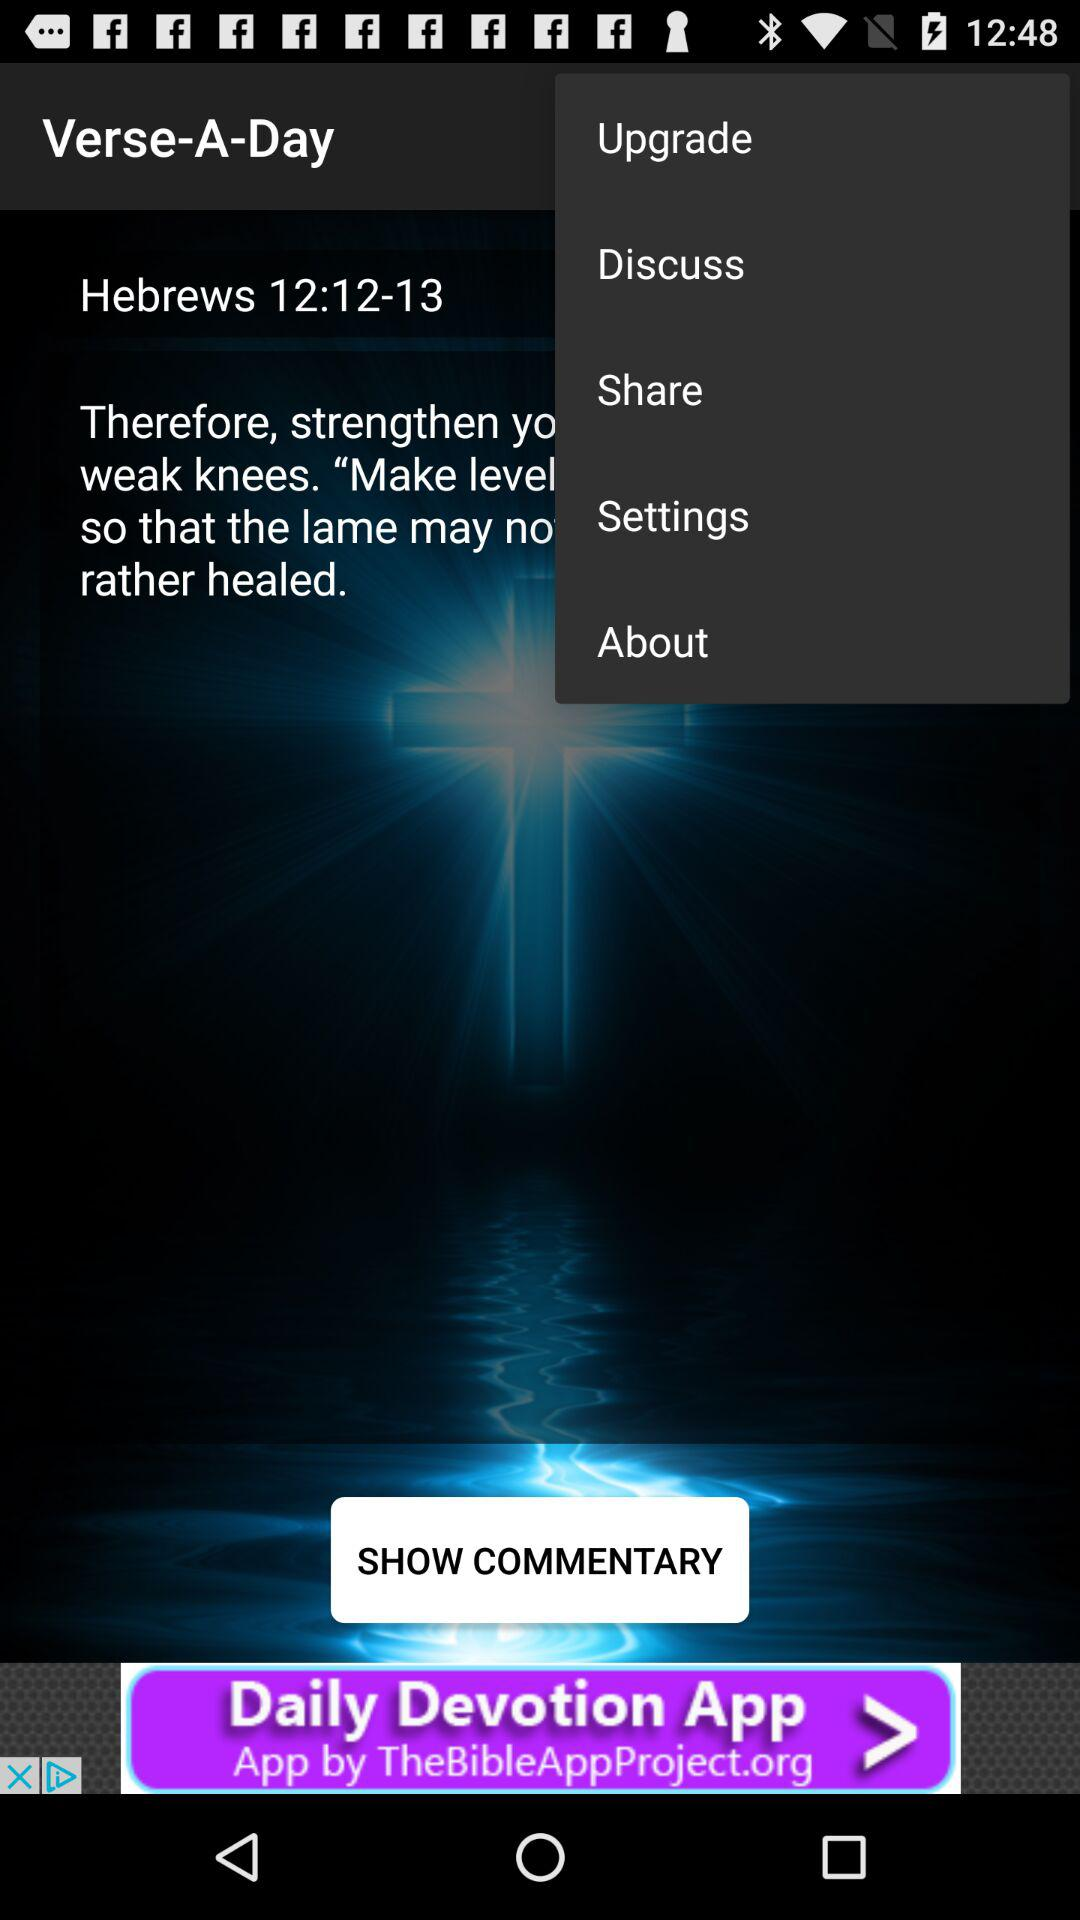What is the app name? The app name is "Verse-A-Day". 